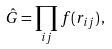<formula> <loc_0><loc_0><loc_500><loc_500>\hat { G } = \prod _ { i j } f ( r _ { i j } ) \, ,</formula> 